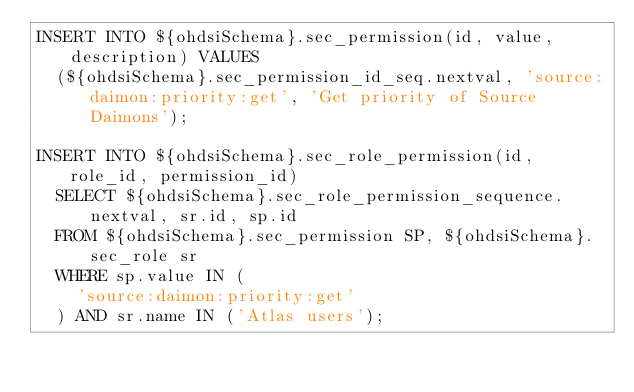Convert code to text. <code><loc_0><loc_0><loc_500><loc_500><_SQL_>INSERT INTO ${ohdsiSchema}.sec_permission(id, value, description) VALUES
  (${ohdsiSchema}.sec_permission_id_seq.nextval, 'source:daimon:priority:get', 'Get priority of Source Daimons');

INSERT INTO ${ohdsiSchema}.sec_role_permission(id, role_id, permission_id)
  SELECT ${ohdsiSchema}.sec_role_permission_sequence.nextval, sr.id, sp.id
  FROM ${ohdsiSchema}.sec_permission SP, ${ohdsiSchema}.sec_role sr
  WHERE sp.value IN (
    'source:daimon:priority:get'
  ) AND sr.name IN ('Atlas users');</code> 